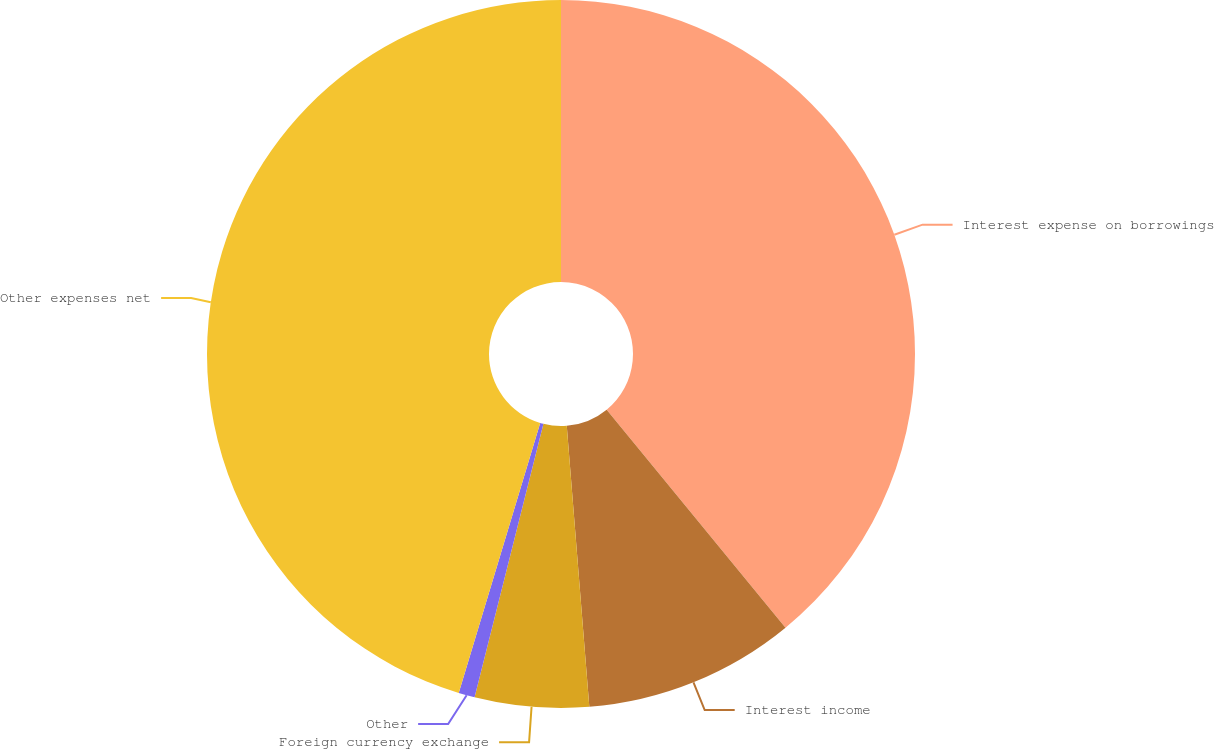Convert chart. <chart><loc_0><loc_0><loc_500><loc_500><pie_chart><fcel>Interest expense on borrowings<fcel>Interest income<fcel>Foreign currency exchange<fcel>Other<fcel>Other expenses net<nl><fcel>39.07%<fcel>9.66%<fcel>5.2%<fcel>0.74%<fcel>45.34%<nl></chart> 